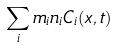Convert formula to latex. <formula><loc_0><loc_0><loc_500><loc_500>\sum _ { i } m _ { i } n _ { i } C _ { i } ( x , t )</formula> 